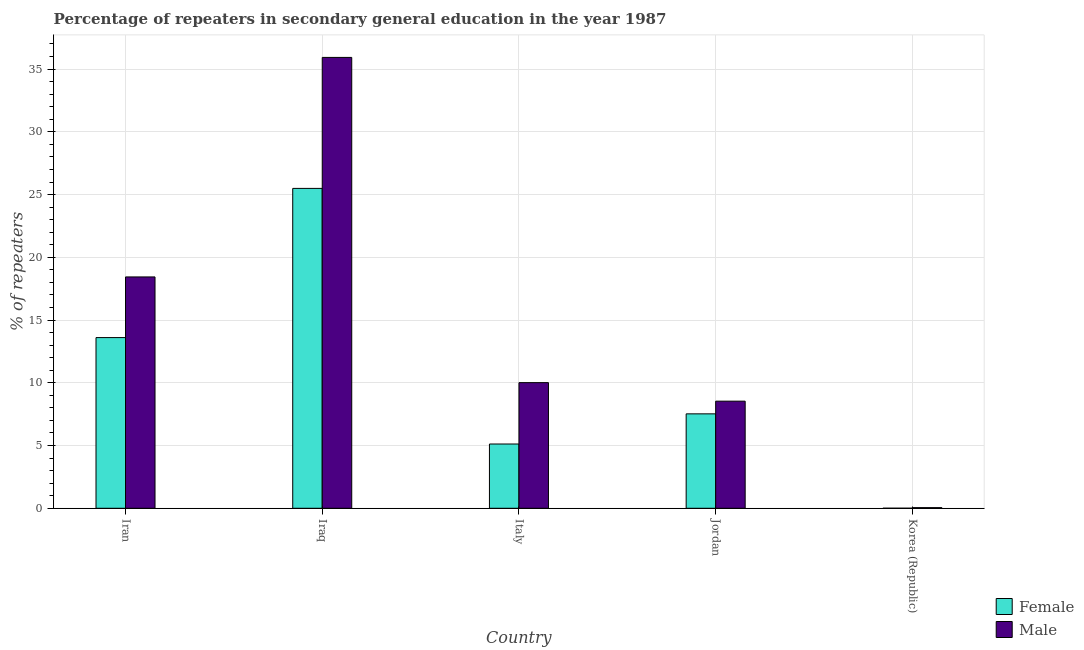Are the number of bars per tick equal to the number of legend labels?
Your answer should be compact. Yes. What is the label of the 5th group of bars from the left?
Provide a short and direct response. Korea (Republic). What is the percentage of male repeaters in Jordan?
Keep it short and to the point. 8.54. Across all countries, what is the maximum percentage of male repeaters?
Offer a very short reply. 35.93. Across all countries, what is the minimum percentage of female repeaters?
Your response must be concise. 0. In which country was the percentage of male repeaters maximum?
Your answer should be very brief. Iraq. In which country was the percentage of female repeaters minimum?
Provide a succinct answer. Korea (Republic). What is the total percentage of female repeaters in the graph?
Give a very brief answer. 51.74. What is the difference between the percentage of female repeaters in Iran and that in Korea (Republic)?
Make the answer very short. 13.6. What is the difference between the percentage of female repeaters in Iran and the percentage of male repeaters in Jordan?
Keep it short and to the point. 5.07. What is the average percentage of male repeaters per country?
Provide a short and direct response. 14.59. What is the difference between the percentage of female repeaters and percentage of male repeaters in Italy?
Your answer should be compact. -4.89. In how many countries, is the percentage of female repeaters greater than 2 %?
Ensure brevity in your answer.  4. What is the ratio of the percentage of male repeaters in Italy to that in Korea (Republic)?
Provide a short and direct response. 200.08. Is the difference between the percentage of female repeaters in Iran and Iraq greater than the difference between the percentage of male repeaters in Iran and Iraq?
Provide a succinct answer. Yes. What is the difference between the highest and the second highest percentage of female repeaters?
Provide a short and direct response. 11.89. What is the difference between the highest and the lowest percentage of female repeaters?
Your response must be concise. 25.49. Is the sum of the percentage of male repeaters in Jordan and Korea (Republic) greater than the maximum percentage of female repeaters across all countries?
Ensure brevity in your answer.  No. What does the 2nd bar from the left in Jordan represents?
Ensure brevity in your answer.  Male. Are the values on the major ticks of Y-axis written in scientific E-notation?
Your answer should be compact. No. How many legend labels are there?
Make the answer very short. 2. How are the legend labels stacked?
Provide a succinct answer. Vertical. What is the title of the graph?
Your response must be concise. Percentage of repeaters in secondary general education in the year 1987. Does "GDP" appear as one of the legend labels in the graph?
Your answer should be compact. No. What is the label or title of the Y-axis?
Provide a short and direct response. % of repeaters. What is the % of repeaters of Female in Iran?
Provide a succinct answer. 13.6. What is the % of repeaters of Male in Iran?
Make the answer very short. 18.44. What is the % of repeaters in Female in Iraq?
Offer a very short reply. 25.49. What is the % of repeaters of Male in Iraq?
Your answer should be compact. 35.93. What is the % of repeaters of Female in Italy?
Ensure brevity in your answer.  5.12. What is the % of repeaters in Male in Italy?
Make the answer very short. 10.01. What is the % of repeaters of Female in Jordan?
Give a very brief answer. 7.52. What is the % of repeaters in Male in Jordan?
Make the answer very short. 8.54. What is the % of repeaters of Female in Korea (Republic)?
Your answer should be very brief. 0. What is the % of repeaters in Male in Korea (Republic)?
Provide a short and direct response. 0.05. Across all countries, what is the maximum % of repeaters of Female?
Offer a terse response. 25.49. Across all countries, what is the maximum % of repeaters of Male?
Ensure brevity in your answer.  35.93. Across all countries, what is the minimum % of repeaters in Female?
Your response must be concise. 0. Across all countries, what is the minimum % of repeaters of Male?
Offer a terse response. 0.05. What is the total % of repeaters of Female in the graph?
Your answer should be compact. 51.74. What is the total % of repeaters in Male in the graph?
Offer a terse response. 72.96. What is the difference between the % of repeaters in Female in Iran and that in Iraq?
Offer a very short reply. -11.89. What is the difference between the % of repeaters of Male in Iran and that in Iraq?
Provide a succinct answer. -17.49. What is the difference between the % of repeaters in Female in Iran and that in Italy?
Keep it short and to the point. 8.48. What is the difference between the % of repeaters of Male in Iran and that in Italy?
Provide a short and direct response. 8.42. What is the difference between the % of repeaters of Female in Iran and that in Jordan?
Provide a short and direct response. 6.08. What is the difference between the % of repeaters of Male in Iran and that in Jordan?
Your answer should be compact. 9.9. What is the difference between the % of repeaters in Female in Iran and that in Korea (Republic)?
Provide a short and direct response. 13.6. What is the difference between the % of repeaters of Male in Iran and that in Korea (Republic)?
Your answer should be compact. 18.39. What is the difference between the % of repeaters of Female in Iraq and that in Italy?
Make the answer very short. 20.37. What is the difference between the % of repeaters in Male in Iraq and that in Italy?
Provide a succinct answer. 25.92. What is the difference between the % of repeaters in Female in Iraq and that in Jordan?
Provide a succinct answer. 17.97. What is the difference between the % of repeaters of Male in Iraq and that in Jordan?
Keep it short and to the point. 27.39. What is the difference between the % of repeaters of Female in Iraq and that in Korea (Republic)?
Your answer should be very brief. 25.49. What is the difference between the % of repeaters in Male in Iraq and that in Korea (Republic)?
Offer a very short reply. 35.88. What is the difference between the % of repeaters of Female in Italy and that in Jordan?
Your response must be concise. -2.4. What is the difference between the % of repeaters of Male in Italy and that in Jordan?
Offer a very short reply. 1.48. What is the difference between the % of repeaters of Female in Italy and that in Korea (Republic)?
Your response must be concise. 5.12. What is the difference between the % of repeaters of Male in Italy and that in Korea (Republic)?
Ensure brevity in your answer.  9.96. What is the difference between the % of repeaters in Female in Jordan and that in Korea (Republic)?
Give a very brief answer. 7.52. What is the difference between the % of repeaters of Male in Jordan and that in Korea (Republic)?
Provide a succinct answer. 8.49. What is the difference between the % of repeaters in Female in Iran and the % of repeaters in Male in Iraq?
Your response must be concise. -22.33. What is the difference between the % of repeaters of Female in Iran and the % of repeaters of Male in Italy?
Keep it short and to the point. 3.59. What is the difference between the % of repeaters in Female in Iran and the % of repeaters in Male in Jordan?
Your response must be concise. 5.07. What is the difference between the % of repeaters in Female in Iran and the % of repeaters in Male in Korea (Republic)?
Ensure brevity in your answer.  13.55. What is the difference between the % of repeaters of Female in Iraq and the % of repeaters of Male in Italy?
Ensure brevity in your answer.  15.48. What is the difference between the % of repeaters in Female in Iraq and the % of repeaters in Male in Jordan?
Keep it short and to the point. 16.96. What is the difference between the % of repeaters in Female in Iraq and the % of repeaters in Male in Korea (Republic)?
Your answer should be compact. 25.44. What is the difference between the % of repeaters in Female in Italy and the % of repeaters in Male in Jordan?
Provide a succinct answer. -3.41. What is the difference between the % of repeaters of Female in Italy and the % of repeaters of Male in Korea (Republic)?
Offer a terse response. 5.07. What is the difference between the % of repeaters of Female in Jordan and the % of repeaters of Male in Korea (Republic)?
Give a very brief answer. 7.47. What is the average % of repeaters in Female per country?
Your answer should be very brief. 10.35. What is the average % of repeaters of Male per country?
Make the answer very short. 14.59. What is the difference between the % of repeaters in Female and % of repeaters in Male in Iran?
Offer a very short reply. -4.83. What is the difference between the % of repeaters in Female and % of repeaters in Male in Iraq?
Provide a short and direct response. -10.44. What is the difference between the % of repeaters of Female and % of repeaters of Male in Italy?
Provide a short and direct response. -4.89. What is the difference between the % of repeaters in Female and % of repeaters in Male in Jordan?
Provide a short and direct response. -1.01. What is the difference between the % of repeaters of Female and % of repeaters of Male in Korea (Republic)?
Your answer should be compact. -0.05. What is the ratio of the % of repeaters of Female in Iran to that in Iraq?
Make the answer very short. 0.53. What is the ratio of the % of repeaters of Male in Iran to that in Iraq?
Ensure brevity in your answer.  0.51. What is the ratio of the % of repeaters in Female in Iran to that in Italy?
Provide a short and direct response. 2.66. What is the ratio of the % of repeaters of Male in Iran to that in Italy?
Provide a short and direct response. 1.84. What is the ratio of the % of repeaters in Female in Iran to that in Jordan?
Offer a very short reply. 1.81. What is the ratio of the % of repeaters in Male in Iran to that in Jordan?
Ensure brevity in your answer.  2.16. What is the ratio of the % of repeaters in Female in Iran to that in Korea (Republic)?
Provide a short and direct response. 3853.25. What is the ratio of the % of repeaters of Male in Iran to that in Korea (Republic)?
Your answer should be compact. 368.41. What is the ratio of the % of repeaters in Female in Iraq to that in Italy?
Your answer should be compact. 4.98. What is the ratio of the % of repeaters in Male in Iraq to that in Italy?
Your answer should be very brief. 3.59. What is the ratio of the % of repeaters of Female in Iraq to that in Jordan?
Offer a terse response. 3.39. What is the ratio of the % of repeaters of Male in Iraq to that in Jordan?
Give a very brief answer. 4.21. What is the ratio of the % of repeaters in Female in Iraq to that in Korea (Republic)?
Make the answer very short. 7221.34. What is the ratio of the % of repeaters in Male in Iraq to that in Korea (Republic)?
Your response must be concise. 718.01. What is the ratio of the % of repeaters of Female in Italy to that in Jordan?
Your response must be concise. 0.68. What is the ratio of the % of repeaters in Male in Italy to that in Jordan?
Provide a short and direct response. 1.17. What is the ratio of the % of repeaters of Female in Italy to that in Korea (Republic)?
Offer a very short reply. 1450.86. What is the ratio of the % of repeaters in Male in Italy to that in Korea (Republic)?
Give a very brief answer. 200.08. What is the ratio of the % of repeaters of Female in Jordan to that in Korea (Republic)?
Your response must be concise. 2131.4. What is the ratio of the % of repeaters in Male in Jordan to that in Korea (Republic)?
Offer a terse response. 170.57. What is the difference between the highest and the second highest % of repeaters of Female?
Offer a terse response. 11.89. What is the difference between the highest and the second highest % of repeaters in Male?
Offer a terse response. 17.49. What is the difference between the highest and the lowest % of repeaters of Female?
Make the answer very short. 25.49. What is the difference between the highest and the lowest % of repeaters of Male?
Your response must be concise. 35.88. 